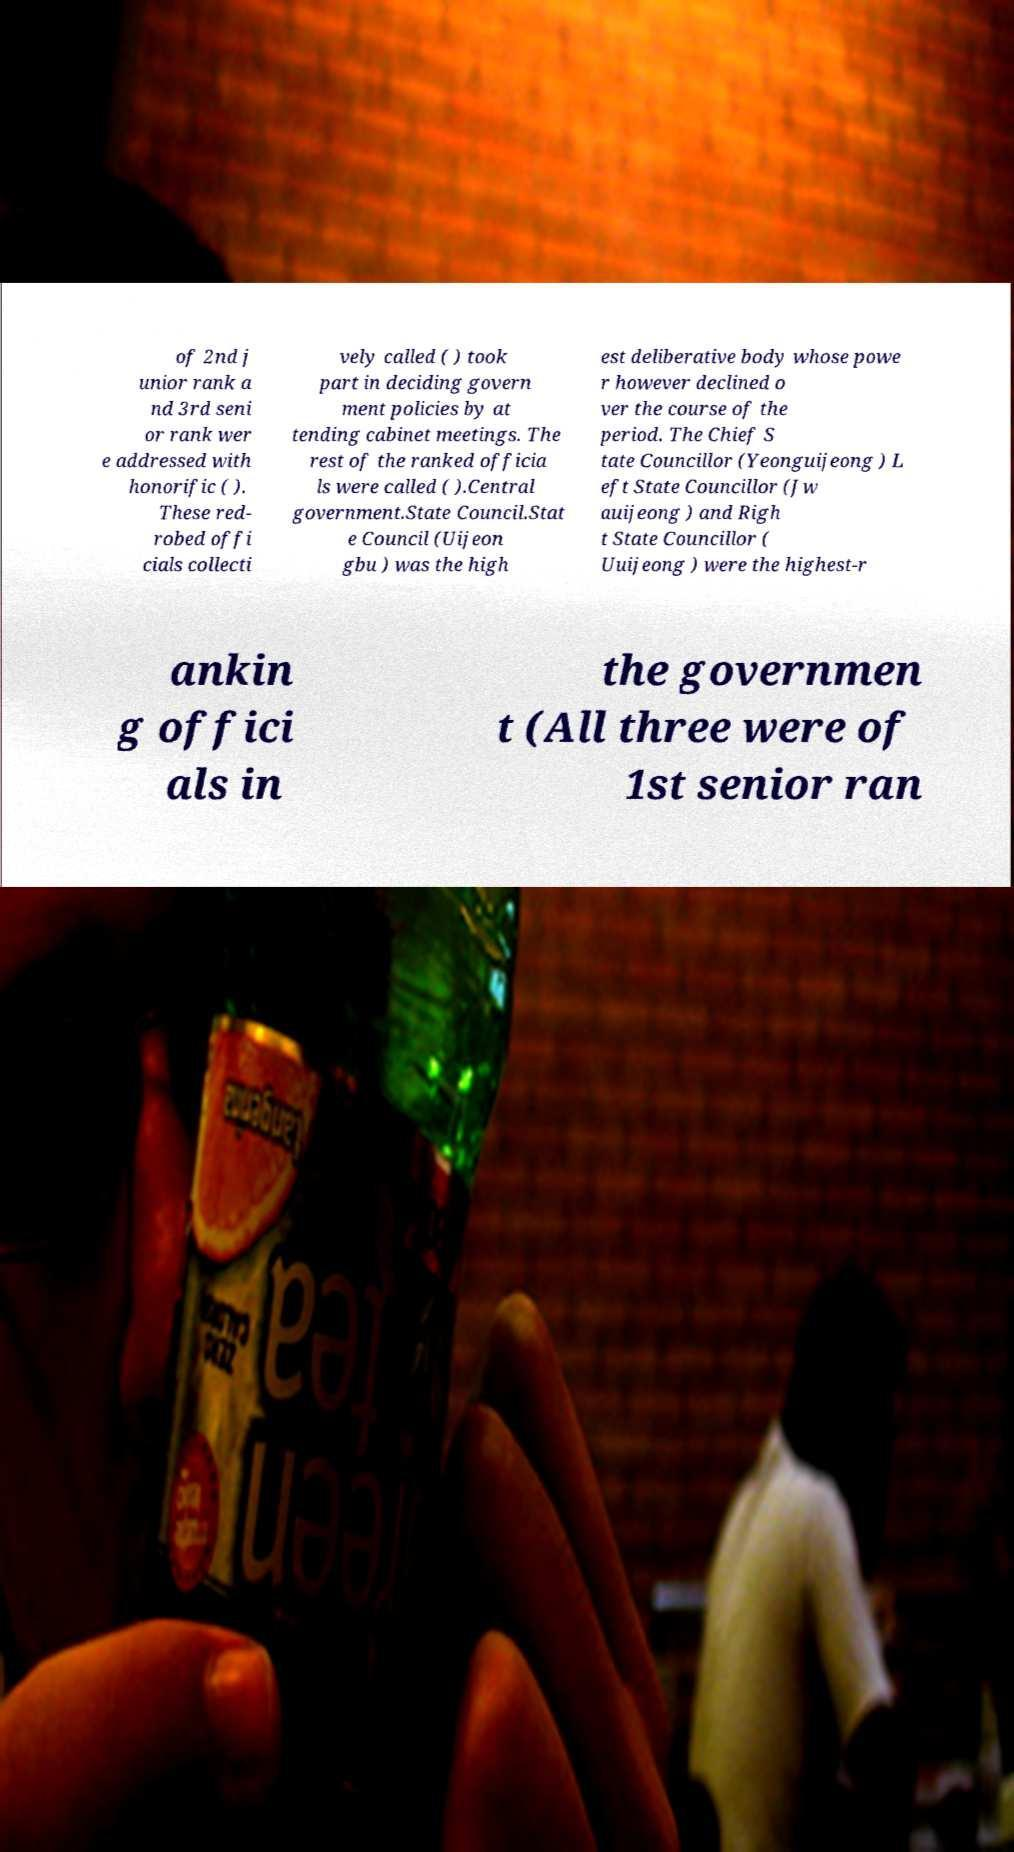I need the written content from this picture converted into text. Can you do that? of 2nd j unior rank a nd 3rd seni or rank wer e addressed with honorific ( ). These red- robed offi cials collecti vely called ( ) took part in deciding govern ment policies by at tending cabinet meetings. The rest of the ranked officia ls were called ( ).Central government.State Council.Stat e Council (Uijeon gbu ) was the high est deliberative body whose powe r however declined o ver the course of the period. The Chief S tate Councillor (Yeonguijeong ) L eft State Councillor (Jw auijeong ) and Righ t State Councillor ( Uuijeong ) were the highest-r ankin g offici als in the governmen t (All three were of 1st senior ran 